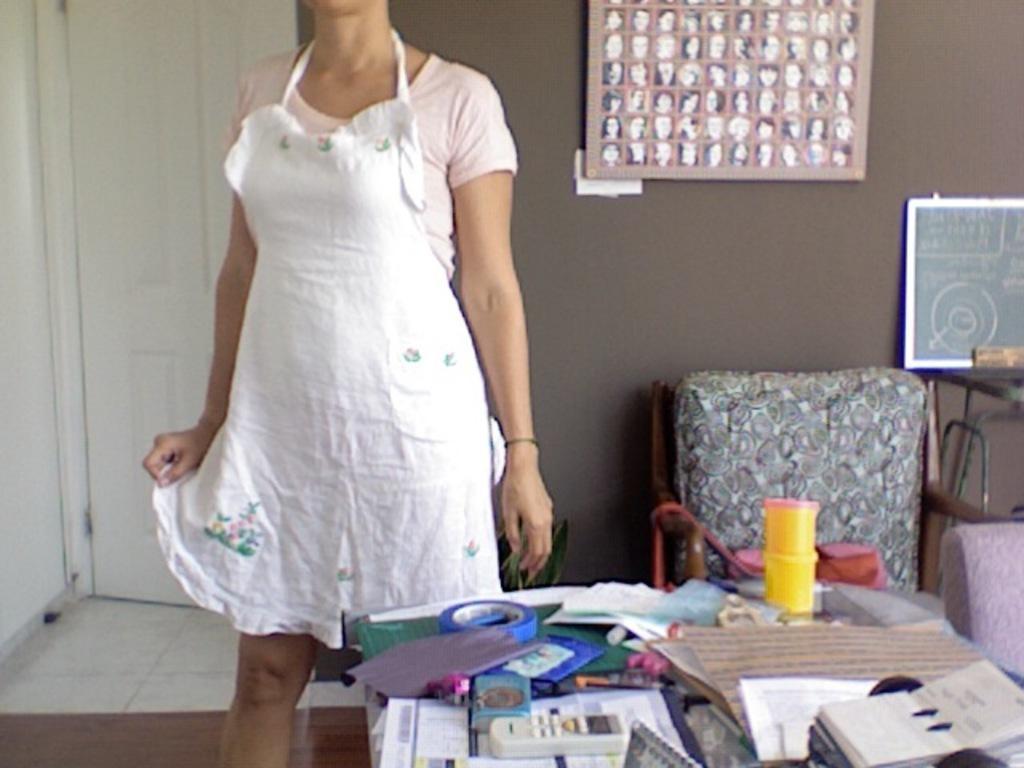Could you give a brief overview of what you see in this image? This is the picture of a room. In this image there is a woman standing. There are papers and there is a remote, plaster and other objects on the table. At the back there are chairs and there is a board on the table. There is a frame and switch board on the wall. At the back there is a door. At the bottom there is a mat. 